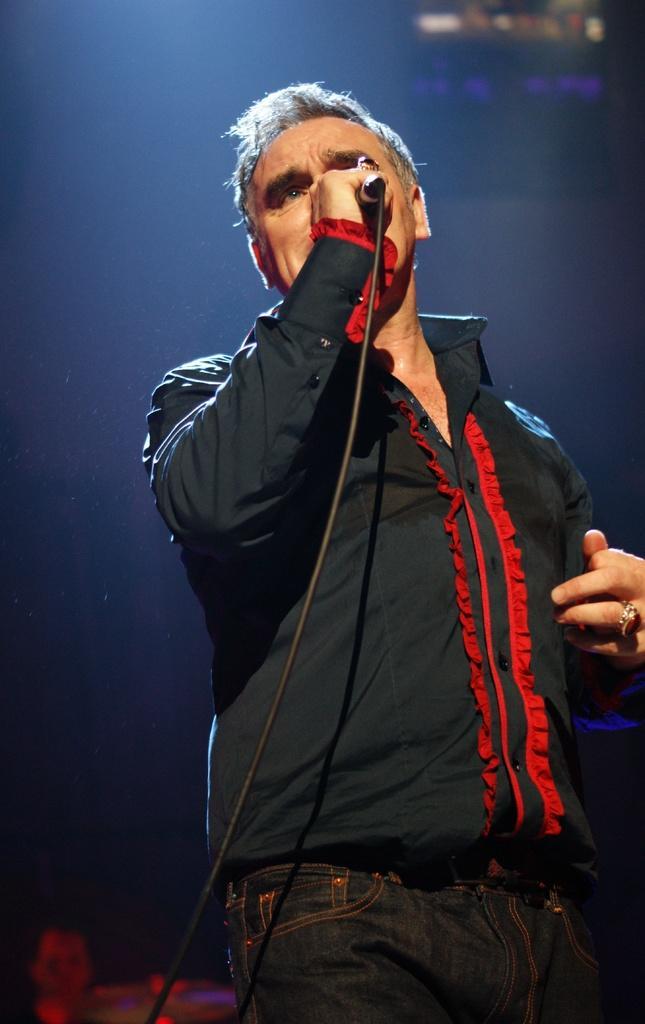In one or two sentences, can you explain what this image depicts? This picture shows a man standing and singing with the help of a microphone 